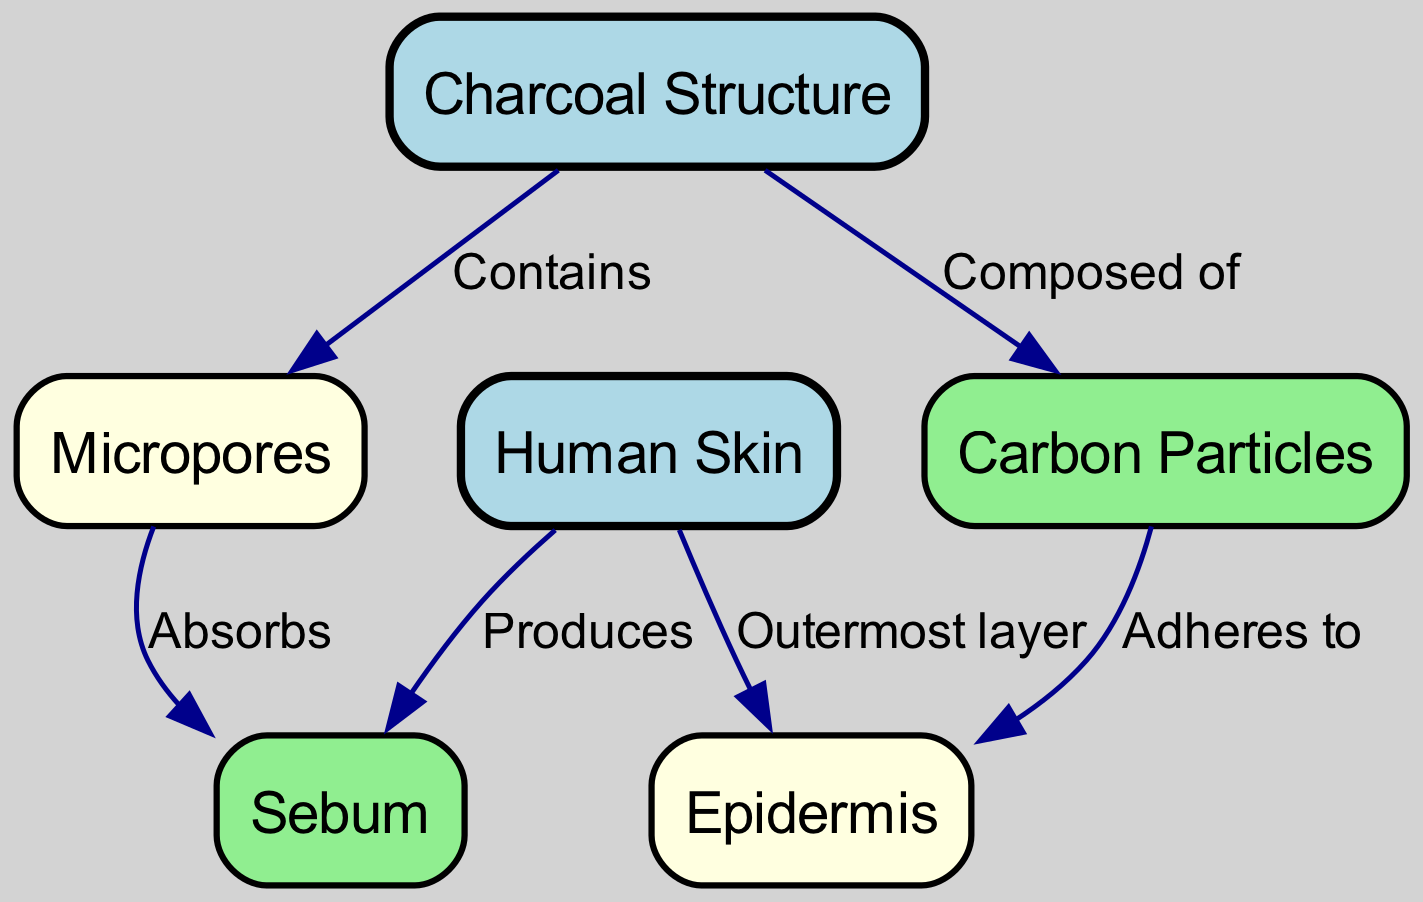What is contained in the charcoal structure? The edge between "charcoal" and "pores" indicates that charcoal contains micropores.
Answer: Micropores What are the particles that make up charcoal? The edge from "charcoal" to "carbon" specifies that charcoal is composed of carbon particles.
Answer: Carbon particles How many nodes are there in the diagram? There are a total of six nodes: charcoal, micropores, carbon particles, human skin, epidermis, and sebum.
Answer: 6 What does the skin produce? The edge indicating the relationship between "skin" and "sebum" states that human skin produces sebum.
Answer: Sebum What part of the skin is the outermost layer? The connection between "skin" and "epidermis" indicates that the epidermis is the outermost layer of the human skin.
Answer: Epidermis How does sebum interact with micropores? The diagram shows an edge stating that micropores absorb sebum, indicating a direct interaction between them.
Answer: Absorbs What type of structure is charcoal described as? The label of the node "charcoal" defines it as having a structure, particularly focusing on its micropores.
Answer: Structure How do carbon particles interact with the epidermis? The edge from "carbon" to "epidermis" illustrates that carbon particles adhere to the epidermis, showing their interaction.
Answer: Adheres to What is produced by the epidermis? The diagram does not directly specify what is produced by the epidermis, but it implies that it relates to skin functions.
Answer: Not specified 